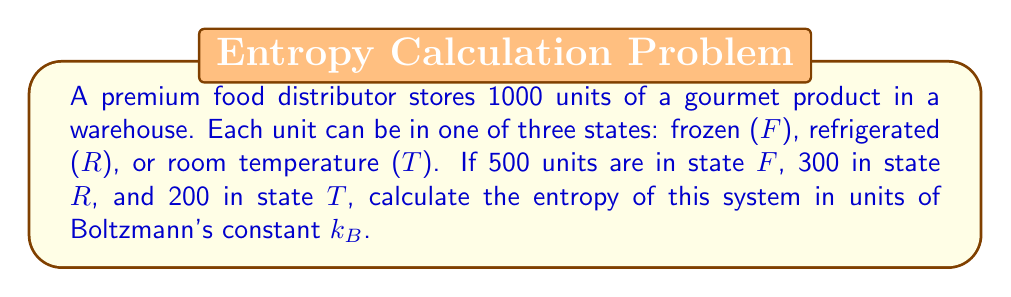Solve this math problem. To calculate the entropy of this system, we'll use the Boltzmann entropy formula:

$$S = k_B \ln W$$

Where $S$ is entropy, $k_B$ is Boltzmann's constant, and $W$ is the number of microstates.

For this system:
1. Total units: $N = 1000$
2. Units in state $F$: $N_F = 500$
3. Units in state $R$: $N_R = 300$
4. Units in state $T$: $N_T = 200$

The number of microstates $W$ is given by the multinomial coefficient:

$$W = \frac{N!}{N_F! N_R! N_T!}$$

Substituting the values:

$$W = \frac{1000!}{500! 300! 200!}$$

Taking the natural logarithm:

$$\ln W = \ln(1000!) - \ln(500!) - \ln(300!) - \ln(200!)$$

Using Stirling's approximation ($\ln(n!) \approx n \ln(n) - n$ for large $n$):

$$\begin{align*}
\ln W &\approx (1000 \ln(1000) - 1000) - (500 \ln(500) - 500) \\
&\quad - (300 \ln(300) - 300) - (200 \ln(200) - 200) \\
&= 1000 \ln(1000) - 500 \ln(500) - 300 \ln(300) - 200 \ln(200) \\
&\approx 6907.76 - 3216.79 - 1702.65 - 1060.21 \\
&\approx 928.11
\end{align*}$$

Therefore, the entropy is:

$$S = k_B \ln W \approx 928.11 k_B$$
Answer: $928.11 k_B$ 